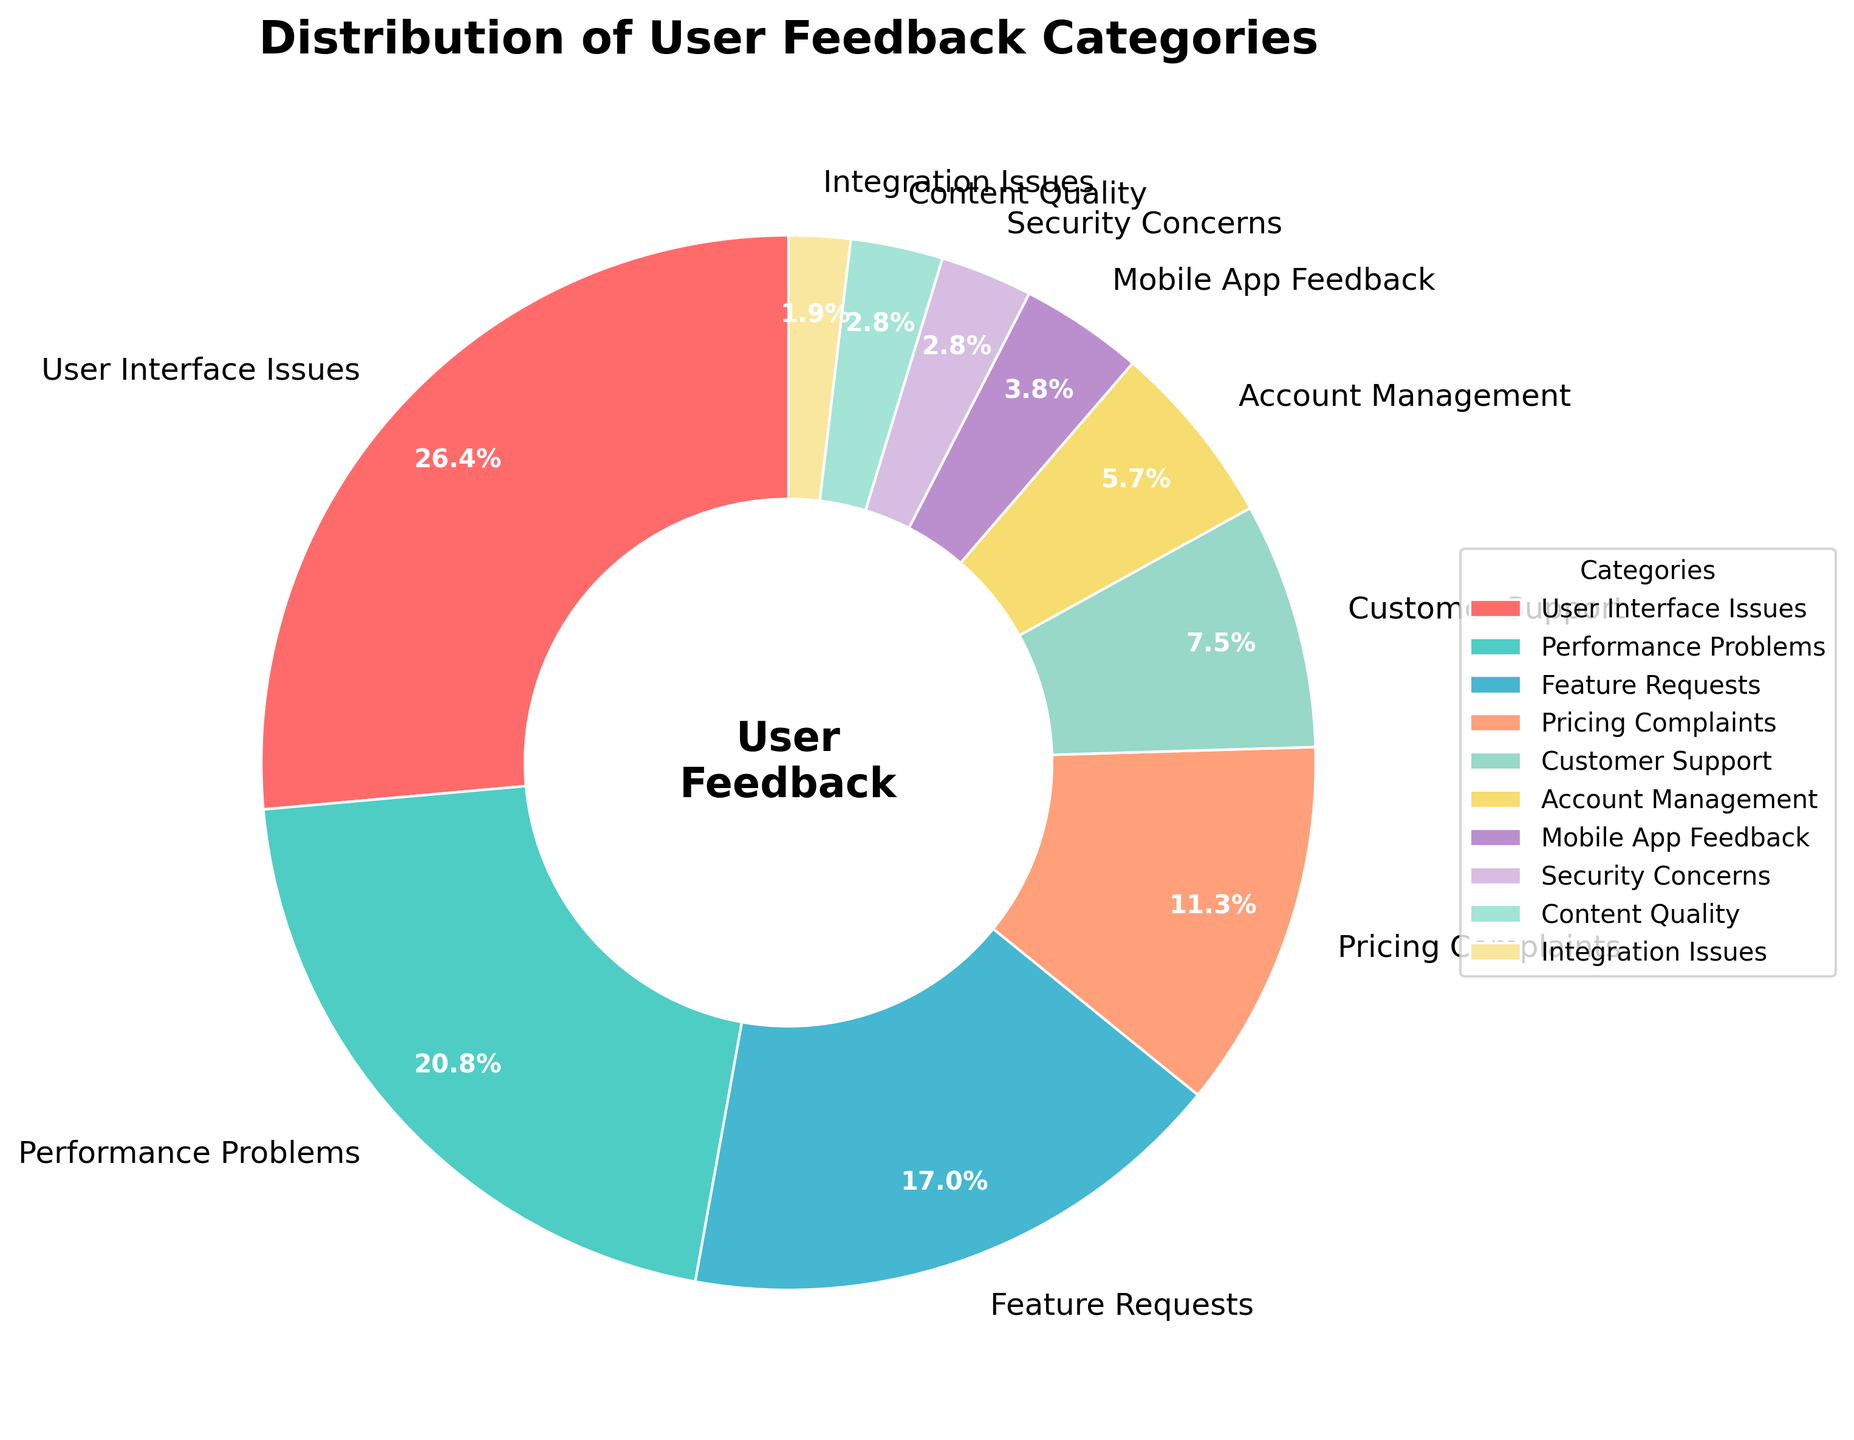What category has the highest percentage of feedback? To determine the category with the highest percentage, we look for the largest section of the pie chart. It is labeled "User Interface Issues" with 28%.
Answer: User Interface Issues Which two categories combined make up exactly 30% of the feedback? We need to find two categories whose percentages sum up to 30. Combining "Customer Support" (8%) and "Pricing Complaints" (12%) gives 20%, then adding "Mobile App Feedback" (4%) brings it to 24%, and finally adding "Integration Issues" (2%) makes it 26%.
Answer: Customer Support and Mobile App Feedback What is the difference in percentage between the most and the least reported feedback categories? The most reported feedback category has 28% (User Interface Issues), and the least reported has 2% (Integration Issues). The difference is 28% - 2% = 26%.
Answer: 26% What percentage of feedback is related to "Performance Problems" and "Feature Requests" combined? Combining "Performance Problems" (22%) and "Feature Requests" (18%) gives 22% + 18% = 40%.
Answer: 40% Which category has a percentage closest to 10%? The pie chart shows "Pricing Complaints" at 12%, which is the closest to 10%.
Answer: Pricing Complaints How does the percentage of "Account Management" compare to "Security Concerns"? "Account Management" has 6%, and "Security Concerns" has 3%. 6% > 3%, so "Account Management" is double that of "Security Concerns".
Answer: Account Management is double Security Concerns How many categories have feedback percentages below 5%? Categories with percentages below 5% are: "Mobile App Feedback" (4%), "Security Concerns" (3%), "Content Quality" (3%), and "Integration Issues" (2%). This makes four categories.
Answer: 4 Which categories are represented by shades of green in the pie chart? The chart uses different colors: "Performance Problems" is light green, "Account Management" is a darker green, and "Content Quality" is olive green.
Answer: Performance Problems, Account Management, Content Quality What percentage of feedback falls into categories with less than 10% each? Categories under 10% are: "Customer Support" (8%), "Account Management" (6%), "Mobile App Feedback" (4%), "Security Concerns" (3%), "Content Quality" (3%), "Integration Issues" (2%). Summing these gives 8% + 6% + 4% + 3% + 3% + 2% = 26%.
Answer: 26% 